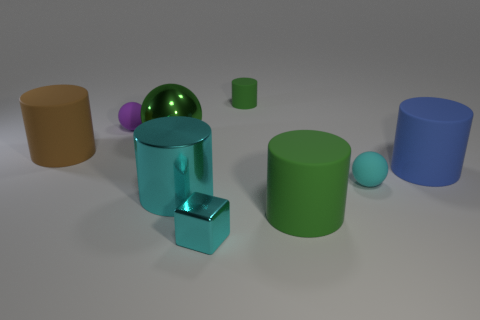How many small matte things have the same color as the big ball?
Offer a very short reply. 1. Is there a metallic thing that is behind the large green thing that is on the right side of the large metal ball?
Offer a very short reply. Yes. What number of rubber objects are right of the large brown cylinder and left of the cyan cylinder?
Make the answer very short. 1. What number of big cylinders have the same material as the small cyan cube?
Offer a very short reply. 1. There is a green rubber cylinder that is to the right of the rubber cylinder that is behind the large green ball; what size is it?
Your answer should be compact. Large. Are there any purple matte things of the same shape as the big brown object?
Your response must be concise. No. There is a cyan shiny thing behind the small cyan block; is its size the same as the green rubber cylinder behind the blue rubber thing?
Your response must be concise. No. Is the number of blue rubber objects that are behind the big blue matte cylinder less than the number of tiny cylinders on the right side of the tiny cylinder?
Offer a very short reply. No. There is another cylinder that is the same color as the small cylinder; what material is it?
Provide a short and direct response. Rubber. What is the color of the big shiny object that is in front of the large blue rubber cylinder?
Make the answer very short. Cyan. 